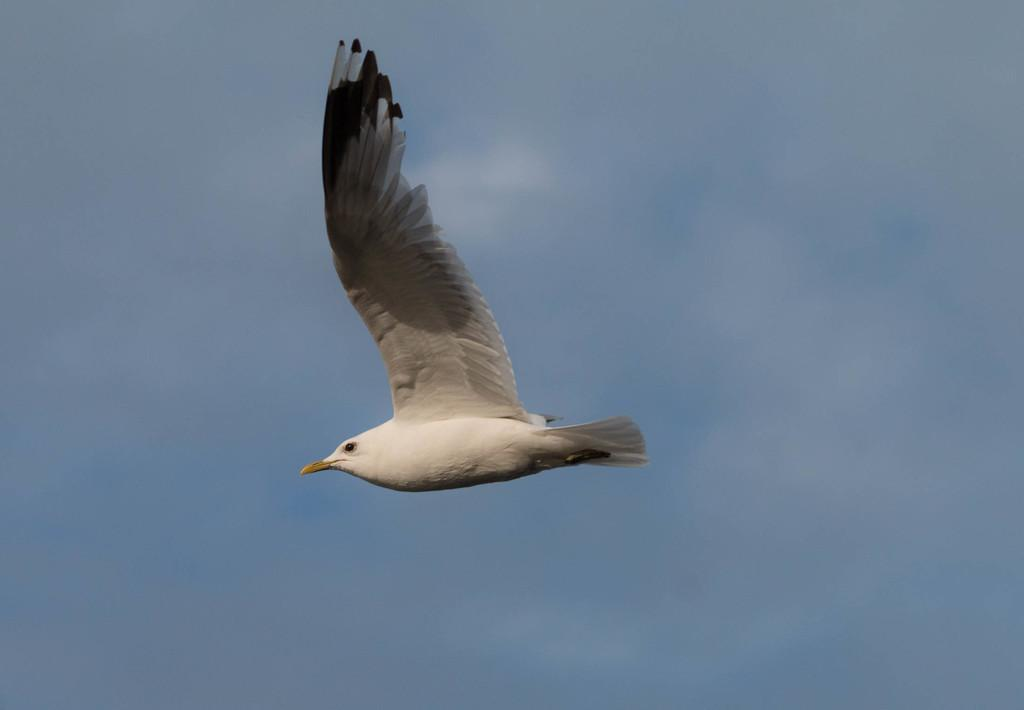What type of animal can be seen in the image? There is a white bird in the image. What is the bird doing in the image? The bird is flying in the sky. the sky. What color is the sky in the image? The sky is blue in color. What type of fruit can be seen growing in the alley in the image? There is no alley or fruit present in the image; it features a white bird flying in the blue sky. 